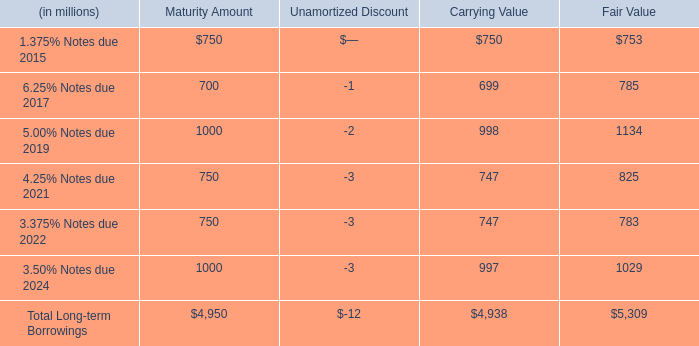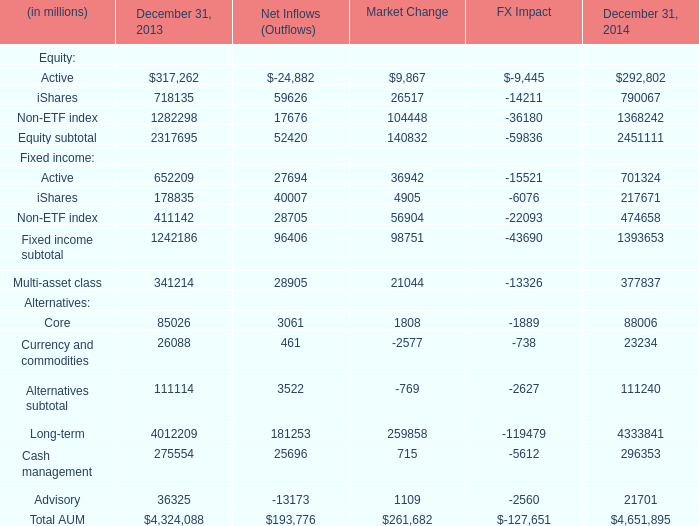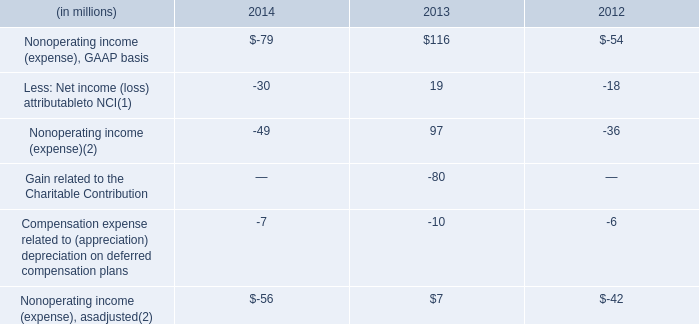What's the total amount of the fixed income in the year where equity subtotal is greater than 2450000? (in dollars in millions) 
Computations: ((((701324 + 217671) + 474658) + 1393653) + 377837)
Answer: 3165143.0. 